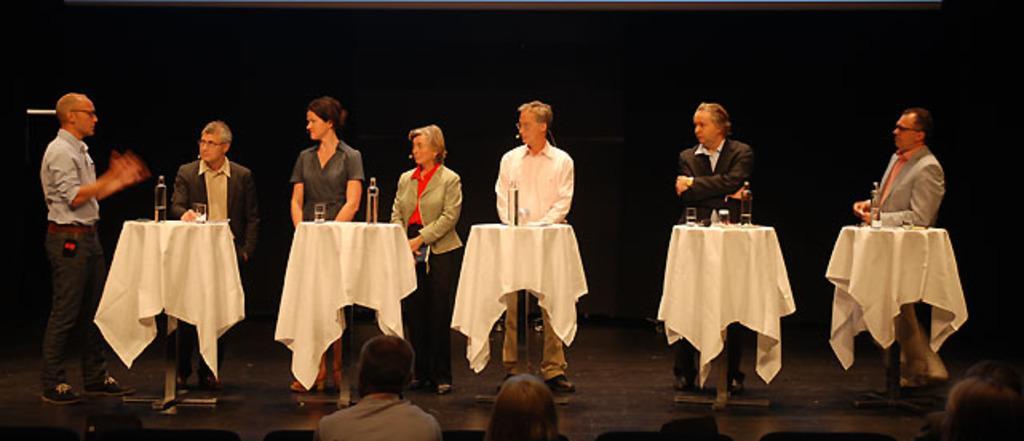Describe this image in one or two sentences. There are people standing and we can see bottles,glasses and clothes on tables. These are audience. Background it is dark. 